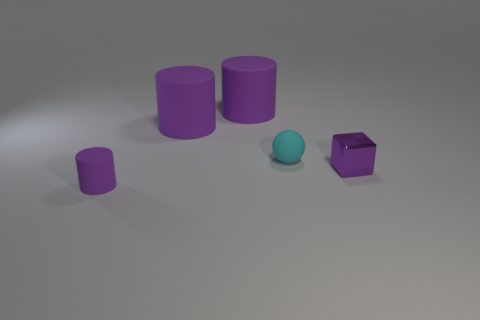Subtract 1 cylinders. How many cylinders are left? 2 Add 4 tiny purple rubber things. How many objects exist? 9 Subtract all balls. How many objects are left? 4 Add 4 cylinders. How many cylinders are left? 7 Add 2 gray metal blocks. How many gray metal blocks exist? 2 Subtract 0 gray cubes. How many objects are left? 5 Subtract all small purple rubber cylinders. Subtract all tiny metallic objects. How many objects are left? 3 